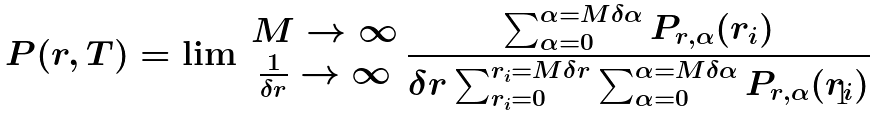<formula> <loc_0><loc_0><loc_500><loc_500>P ( r , T ) = \lim \begin{array} { c } { M \rightarrow \infty } \\ { \frac { 1 } { \delta r } \rightarrow \infty } \end{array} \frac { \sum _ { \alpha = 0 } ^ { \alpha = M \delta \alpha } P _ { r , \alpha } ( r _ { i } ) } { \delta r \sum _ { r _ { i } = 0 } ^ { r _ { i } = M \delta r } \sum _ { \alpha = 0 } ^ { \alpha = M \delta \alpha } P _ { r , \alpha } ( r _ { i } ) }</formula> 